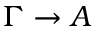<formula> <loc_0><loc_0><loc_500><loc_500>\Gamma \rightarrow A</formula> 